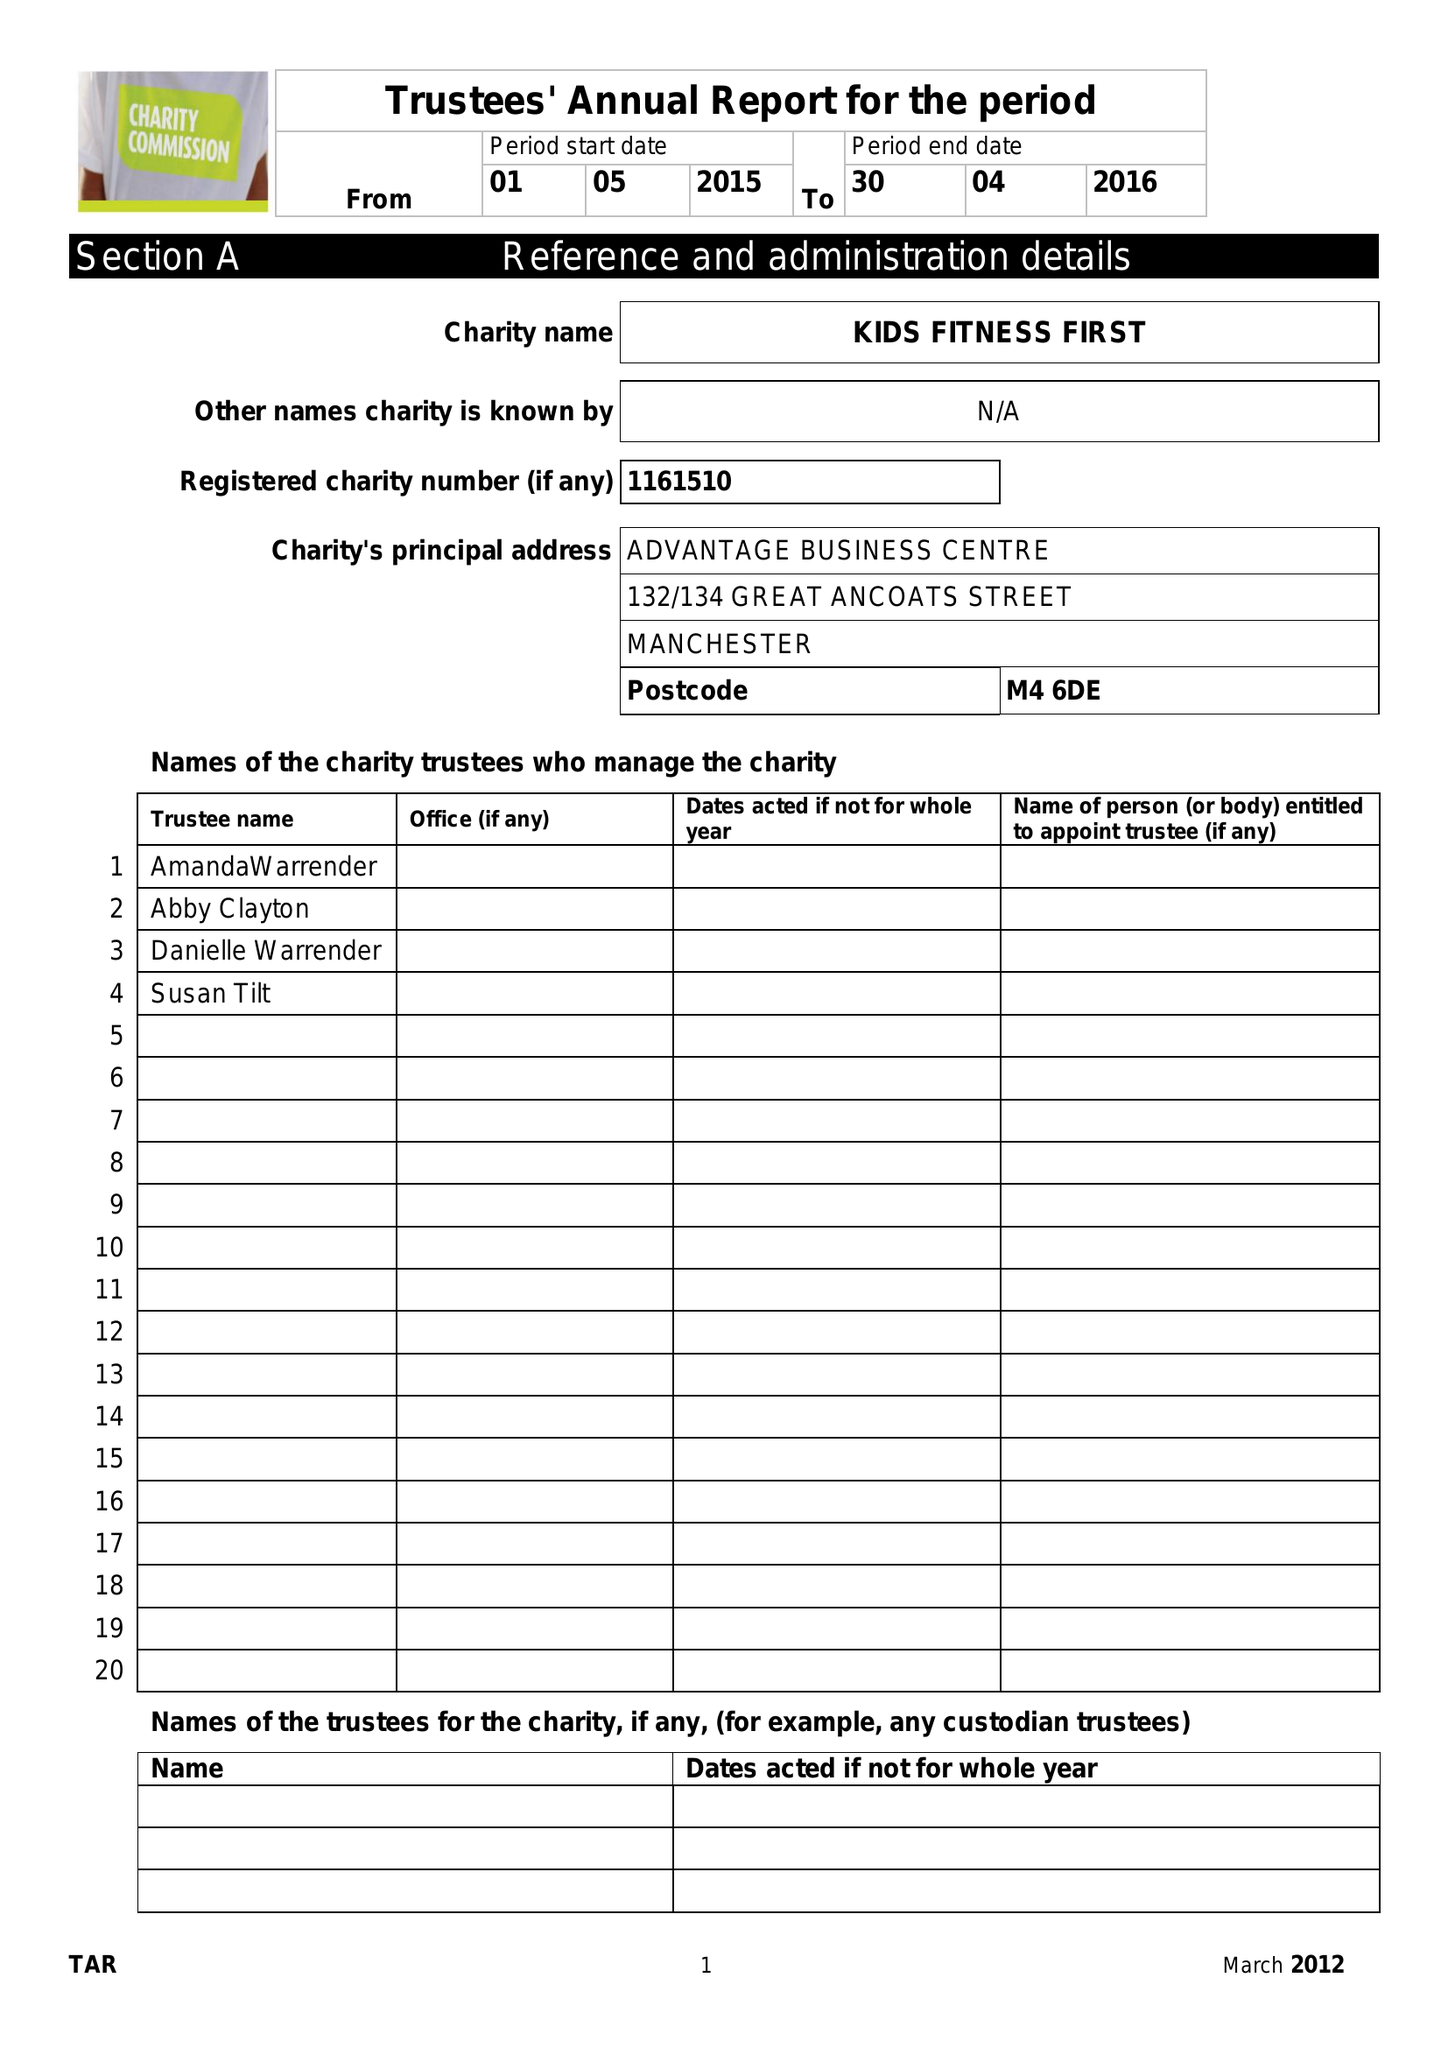What is the value for the report_date?
Answer the question using a single word or phrase. 2016-04-30 